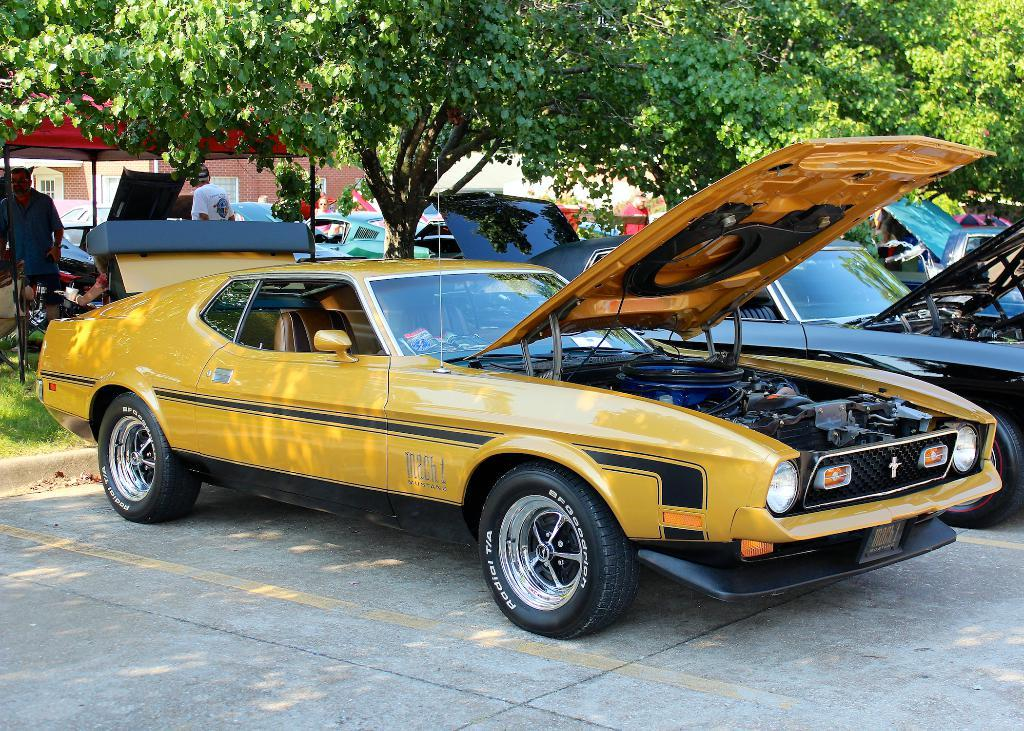What vehicles are present in the image? There are two cars in the image. What type of vegetation can be seen in the image? There are green color trees in the image. Are there any people visible in the image? Yes, there are two persons standing in the background of the image. What type of worm can be seen crawling on the hood of one of the cars in the image? There is no worm present on the cars in the image. 